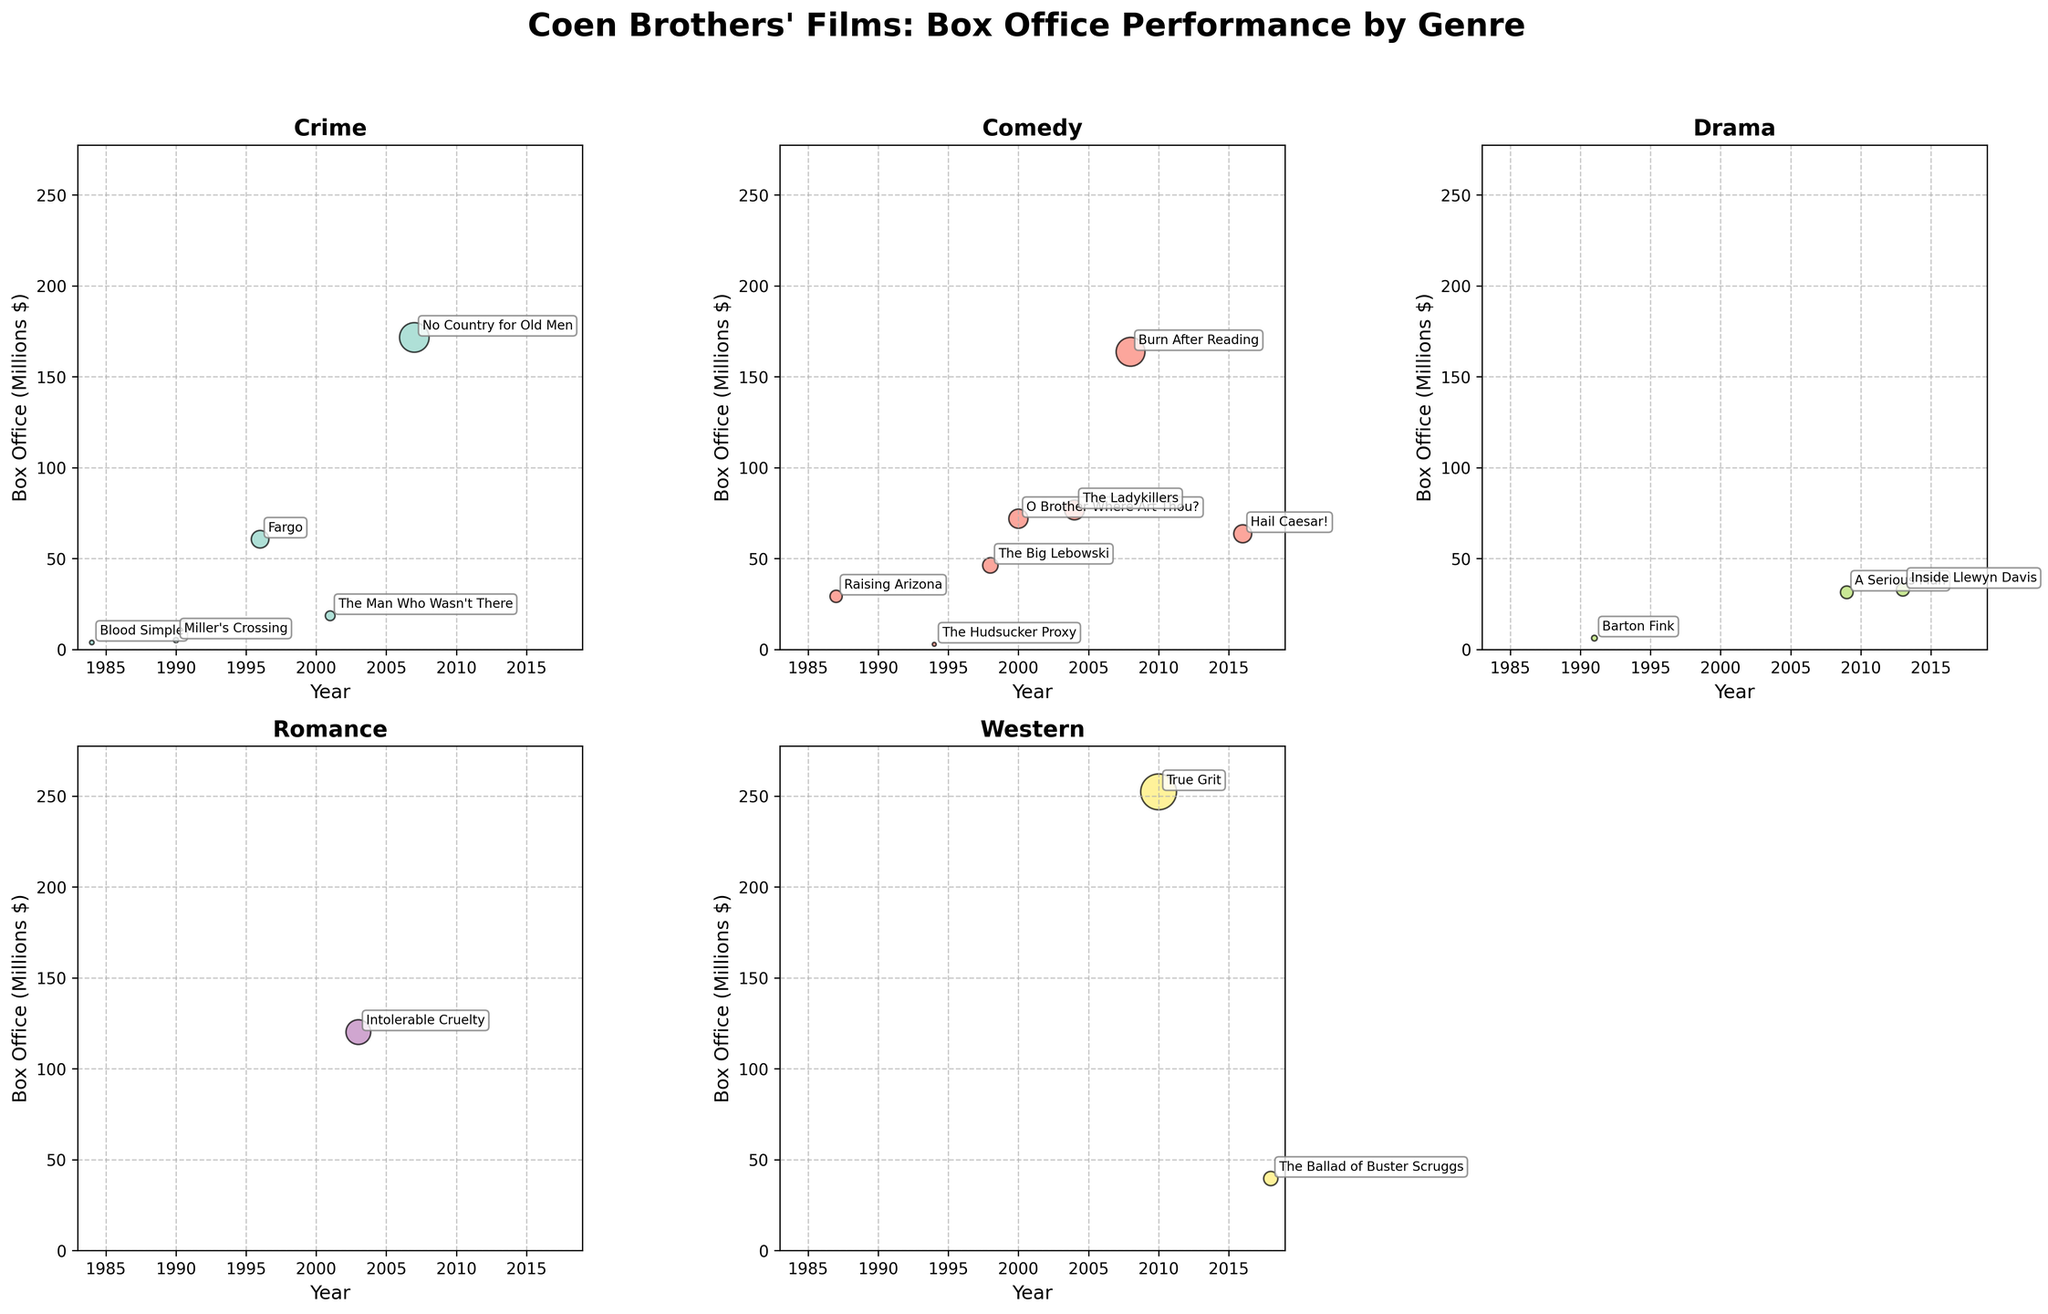What's the highest-grossing film in the "Western" genre? To find this, look at the "Western" subplot and identify the data point with the highest y-coordinate. True Grit has the highest box office revenue in the "Western" genre.
Answer: True Grit How many genres of Coen Brothers' films are displayed in the figure? The figure is divided into subplots, each representing a unique genre. Count the number of subplots titled with distinct genres. There are 5 genres: Crime, Comedy, Drama, Romance, and Western.
Answer: 5 Which genre has the lowest box office performance on average? To determine this, calculate the average box office revenue for each genre by summing the box office figures and dividing by the number of films in each genre. The Drama genre has the lowest average box office performance.
Answer: Drama In which year was the film with the highest box office in the "Comedy" genre released? Look at the "Comedy" subplot, and identify the data point with the highest y-coordinate. Burn After Reading (2008) has the highest box office in the Comedy genre.
Answer: 2008 What was the box office of "The Big Lebowski"? Find the "Comedy" subplot and locate the data point labeled “The Big Lebowski,” then read its y-coordinate. The box office revenue of The Big Lebowski is 46.2 million dollars.
Answer: 46.2 million dollars Which genre saw the most significant increase in its highest-performing film from its first to last listed movie? Look at the highest box office data points in each genre’s subplot from the earliest to the latest film and calculate the difference. Crime increased from 3.8 million in Blood Simple (1984) to 171.6 million in No Country for Old Men (2007).
Answer: Crime Between "O Brother Where Art Thou?" and "The Ladykillers," which film performed better at the box office? Refer to the data points for these films in the "Comedy" subplot and compare their y-coordinates. "The Ladykillers" has a box office of 76.7 million, which is more than "O Brother Where Art Thou?" with 71.9 million.
Answer: The Ladykillers How many films were made in the “Drama” genre? Count the number of data points in the "Drama" subplot. There are 3 films in the "Drama" genre.
Answer: 3 Which genre had the most films released? Compare the number of data points in each genre's subplot. Comedy has the most films released with 6 films.
Answer: Comedy What is the combined box office performance of all "Crime" genre films? Sum up the y-values (box office earnings) from the data points in the "Crime" subplot. The combined box office of Crime films is 3.8 + 5.1 + 60.6 + 18.5 + 171.6 = 259.6 million dollars.
Answer: 259.6 million dollars 